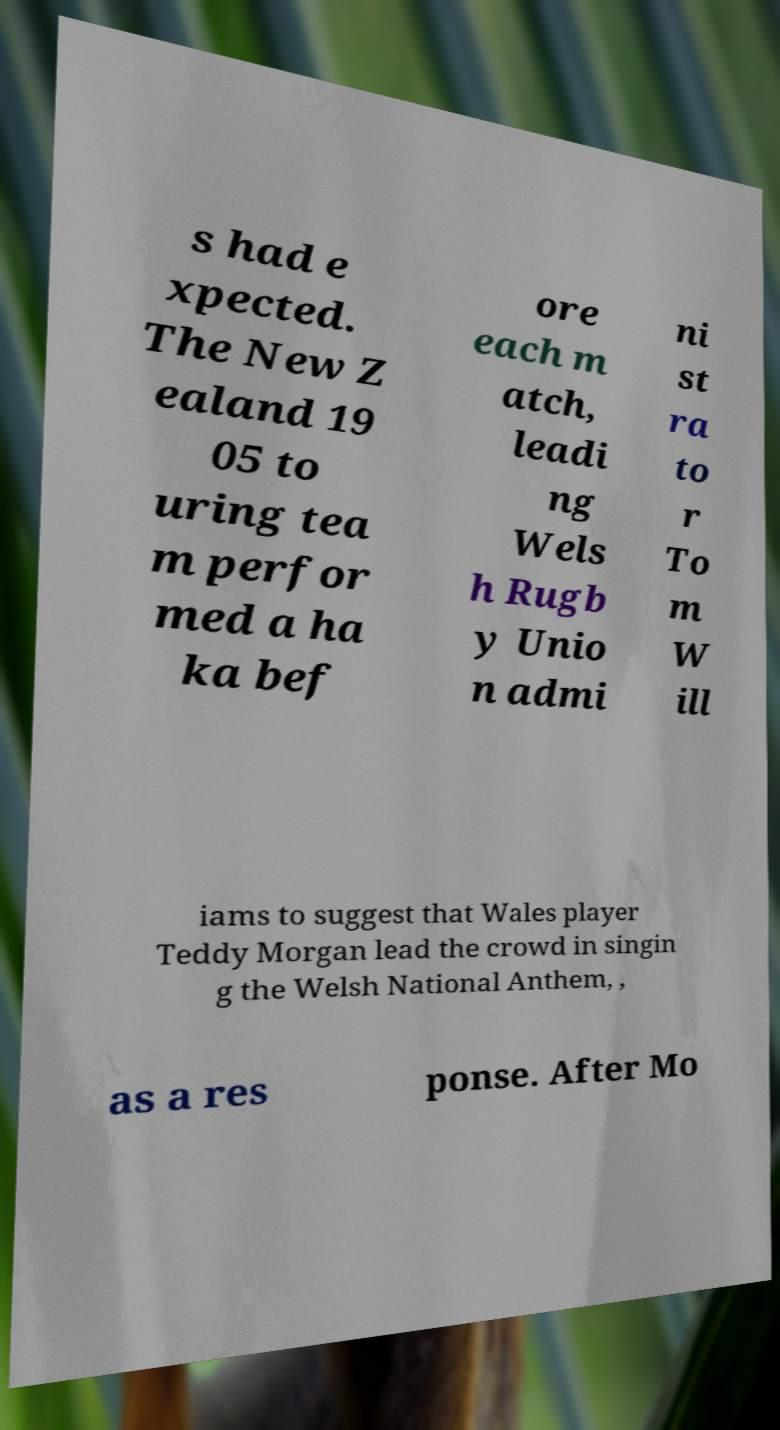Could you extract and type out the text from this image? s had e xpected. The New Z ealand 19 05 to uring tea m perfor med a ha ka bef ore each m atch, leadi ng Wels h Rugb y Unio n admi ni st ra to r To m W ill iams to suggest that Wales player Teddy Morgan lead the crowd in singin g the Welsh National Anthem, , as a res ponse. After Mo 